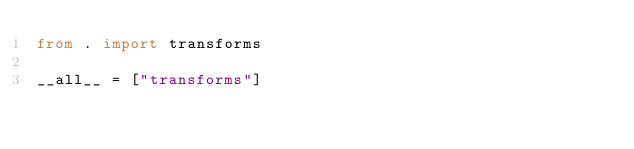Convert code to text. <code><loc_0><loc_0><loc_500><loc_500><_Python_>from . import transforms

__all__ = ["transforms"]
</code> 